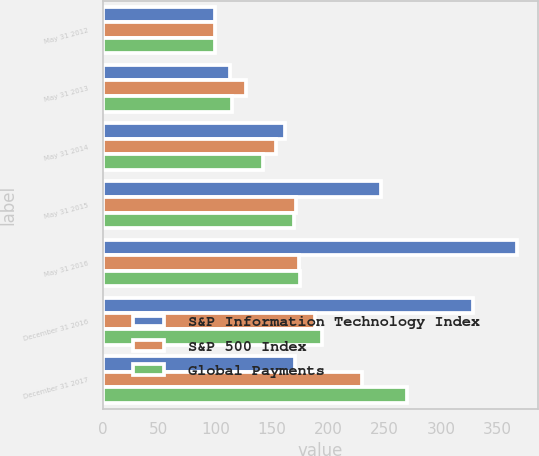Convert chart. <chart><loc_0><loc_0><loc_500><loc_500><stacked_bar_chart><ecel><fcel>May 31 2012<fcel>May 31 2013<fcel>May 31 2014<fcel>May 31 2015<fcel>May 31 2016<fcel>December 31 2016<fcel>December 31 2017<nl><fcel>S&P Information Technology Index<fcel>100<fcel>113.1<fcel>161.9<fcel>246.72<fcel>367.5<fcel>328.42<fcel>170.43<nl><fcel>S&P 500 Index<fcel>100<fcel>127.28<fcel>153.3<fcel>171.4<fcel>174.34<fcel>188.47<fcel>229.61<nl><fcel>Global Payments<fcel>100<fcel>115.12<fcel>142.63<fcel>169.46<fcel>174.75<fcel>194.08<fcel>269.45<nl></chart> 